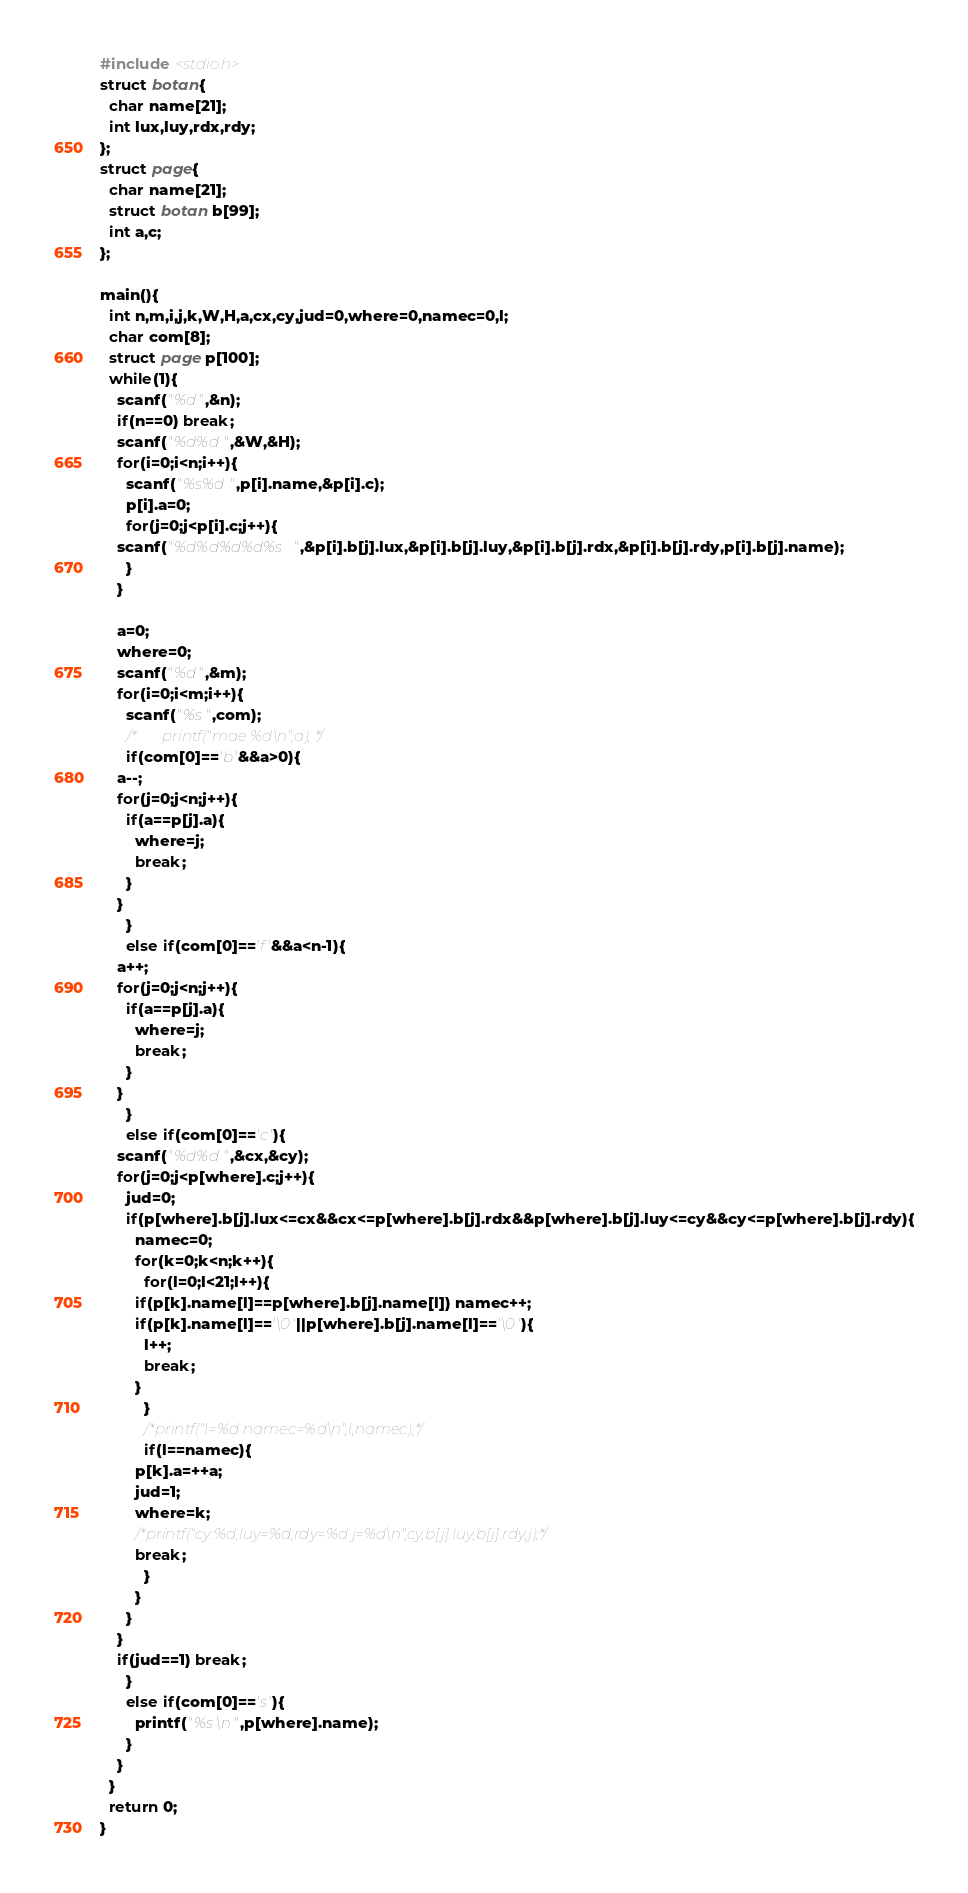Convert code to text. <code><loc_0><loc_0><loc_500><loc_500><_C_>#include <stdio.h>
struct botan{
  char name[21];
  int lux,luy,rdx,rdy;
};
struct page{
  char name[21];
  struct botan b[99];
  int a,c;
};

main(){
  int n,m,i,j,k,W,H,a,cx,cy,jud=0,where=0,namec=0,l;
  char com[8];
  struct page p[100];
  while(1){
    scanf("%d",&n);
    if(n==0) break;
    scanf("%d%d",&W,&H);
    for(i=0;i<n;i++){
      scanf("%s%d",p[i].name,&p[i].c);
      p[i].a=0;
      for(j=0;j<p[i].c;j++){
	scanf("%d%d%d%d%s",&p[i].b[j].lux,&p[i].b[j].luy,&p[i].b[j].rdx,&p[i].b[j].rdy,p[i].b[j].name);
      }
    }

    a=0;
    where=0;
    scanf("%d",&m);
    for(i=0;i<m;i++){
      scanf("%s",com);
      /*       printf("mae %d\n",a); */
      if(com[0]=='b'&&a>0){ 
	a--;
	for(j=0;j<n;j++){
	  if(a==p[j].a){
	    where=j;
	    break;
	  }
	}
      }
      else if(com[0]=='f'&&a<n-1){ 
	a++;
	for(j=0;j<n;j++){
	  if(a==p[j].a){
	    where=j;
	    break;
	  }
	}
      }
      else if(com[0]=='c'){
	scanf("%d%d",&cx,&cy);
	for(j=0;j<p[where].c;j++){
	  jud=0;
	  if(p[where].b[j].lux<=cx&&cx<=p[where].b[j].rdx&&p[where].b[j].luy<=cy&&cy<=p[where].b[j].rdy){
	    namec=0;	    
	    for(k=0;k<n;k++){
	      for(l=0;l<21;l++){
		if(p[k].name[l]==p[where].b[j].name[l]) namec++;
		if(p[k].name[l]=='\0'||p[where].b[j].name[l]=='\0'){
		  l++;
		  break;
		}
	      }
	      /*printf("l=%d namec=%d\n",l,namec);*/
	      if(l==namec){
		p[k].a=++a;
		jud=1;
		where=k;
		/*printf("cy:%d,luy=%d,rdy=%d j=%d\n",cy,b[j].luy,b[j].rdy,j);*/
		break;
	      }
	    }		
	  }
	}
	if(jud==1) break;
      }
      else if(com[0]=='s'){
	    printf("%s\n",p[where].name);
      }
    }
  } 
  return 0;
}</code> 